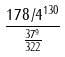Convert formula to latex. <formula><loc_0><loc_0><loc_500><loc_500>\frac { 1 7 8 / 4 ^ { 1 3 0 } } { \frac { 3 7 ^ { 9 } } { 3 2 2 } }</formula> 